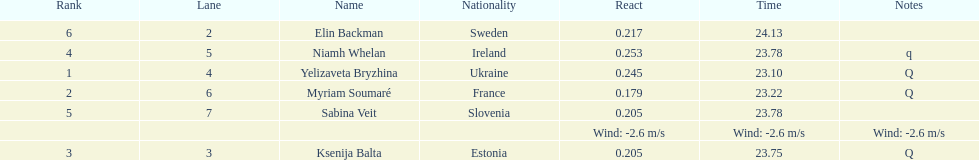Are any of the lanes in consecutive order? No. 